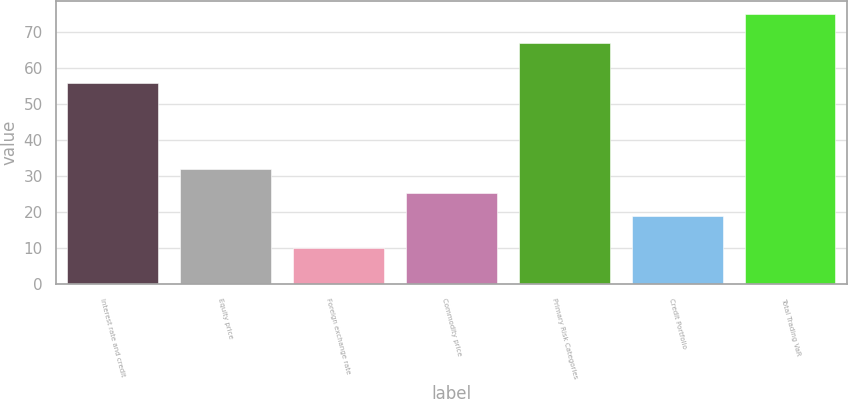Convert chart to OTSL. <chart><loc_0><loc_0><loc_500><loc_500><bar_chart><fcel>Interest rate and credit<fcel>Equity price<fcel>Foreign exchange rate<fcel>Commodity price<fcel>Primary Risk Categories<fcel>Credit Portfolio<fcel>Total Trading VaR<nl><fcel>56<fcel>32<fcel>10<fcel>25.5<fcel>67<fcel>19<fcel>75<nl></chart> 